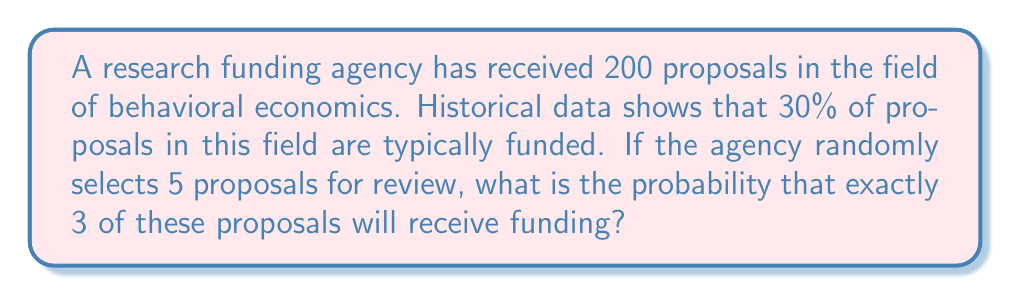Help me with this question. To solve this problem, we need to use the binomial probability formula, as we are dealing with a fixed number of independent trials (selecting 5 proposals) with two possible outcomes for each trial (funded or not funded).

Step 1: Identify the parameters
- $n$ = number of trials = 5
- $p$ = probability of success (funding) for each trial = 0.30
- $k$ = number of successes we're looking for = 3

Step 2: Use the binomial probability formula
$$P(X = k) = \binom{n}{k} p^k (1-p)^{n-k}$$

Step 3: Calculate the binomial coefficient
$$\binom{5}{3} = \frac{5!}{3!(5-3)!} = \frac{5 \cdot 4}{2 \cdot 1} = 10$$

Step 4: Substitute the values into the formula
$$P(X = 3) = 10 \cdot (0.30)^3 \cdot (1-0.30)^{5-3}$$
$$= 10 \cdot (0.30)^3 \cdot (0.70)^2$$

Step 5: Calculate the final probability
$$= 10 \cdot 0.027 \cdot 0.49$$
$$= 0.1323$$

Therefore, the probability of exactly 3 out of 5 randomly selected proposals receiving funding is approximately 0.1323 or 13.23%.
Answer: 0.1323 